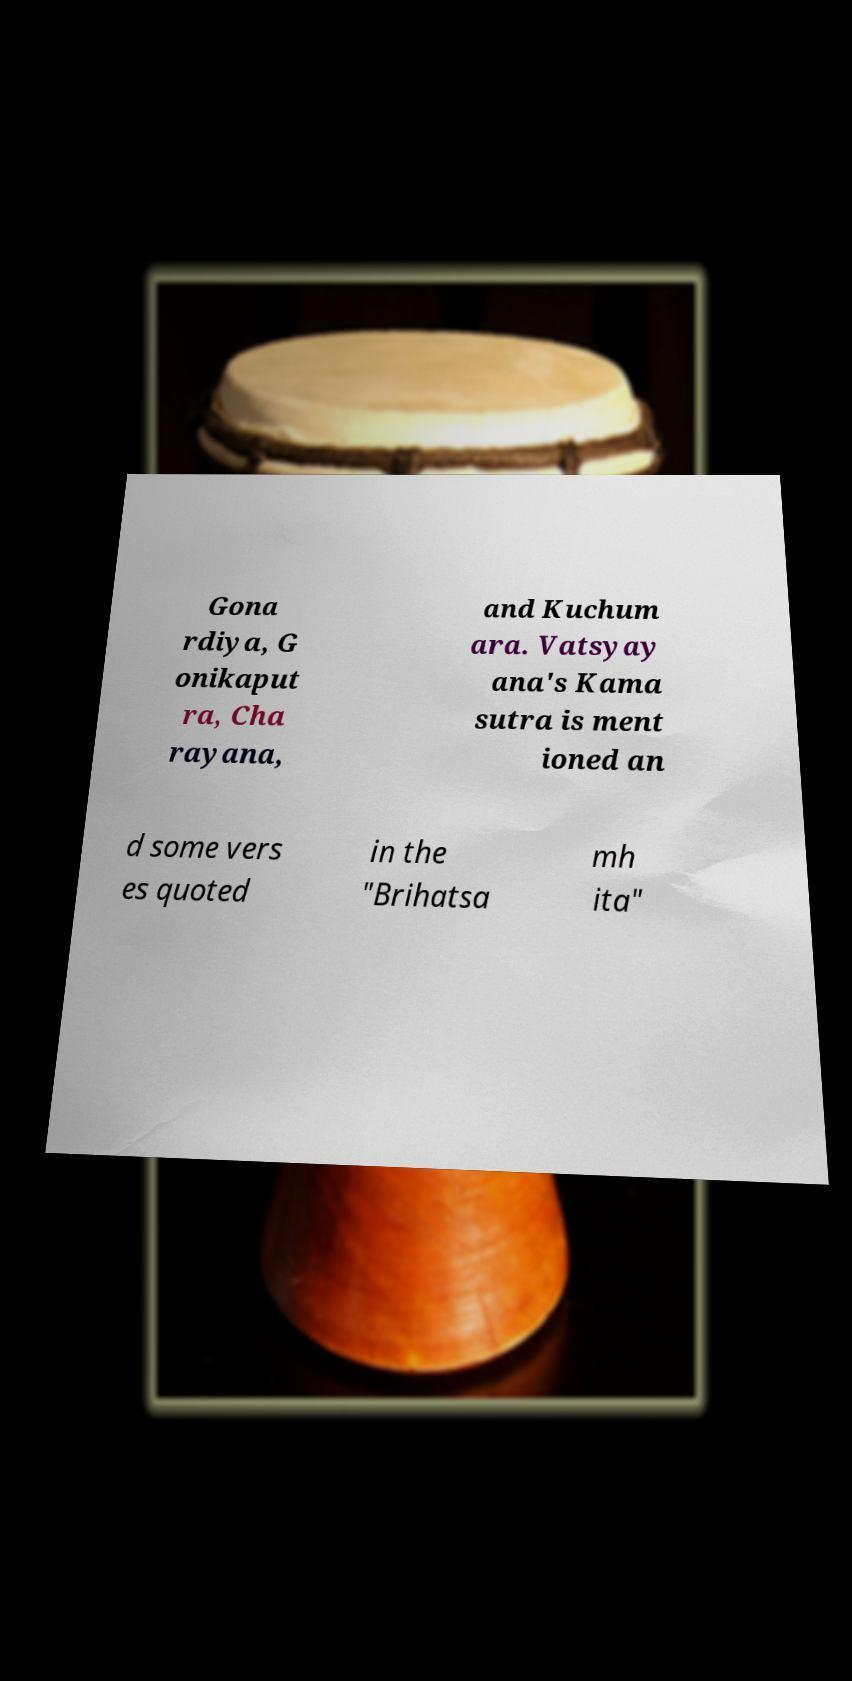There's text embedded in this image that I need extracted. Can you transcribe it verbatim? Gona rdiya, G onikaput ra, Cha rayana, and Kuchum ara. Vatsyay ana's Kama sutra is ment ioned an d some vers es quoted in the "Brihatsa mh ita" 